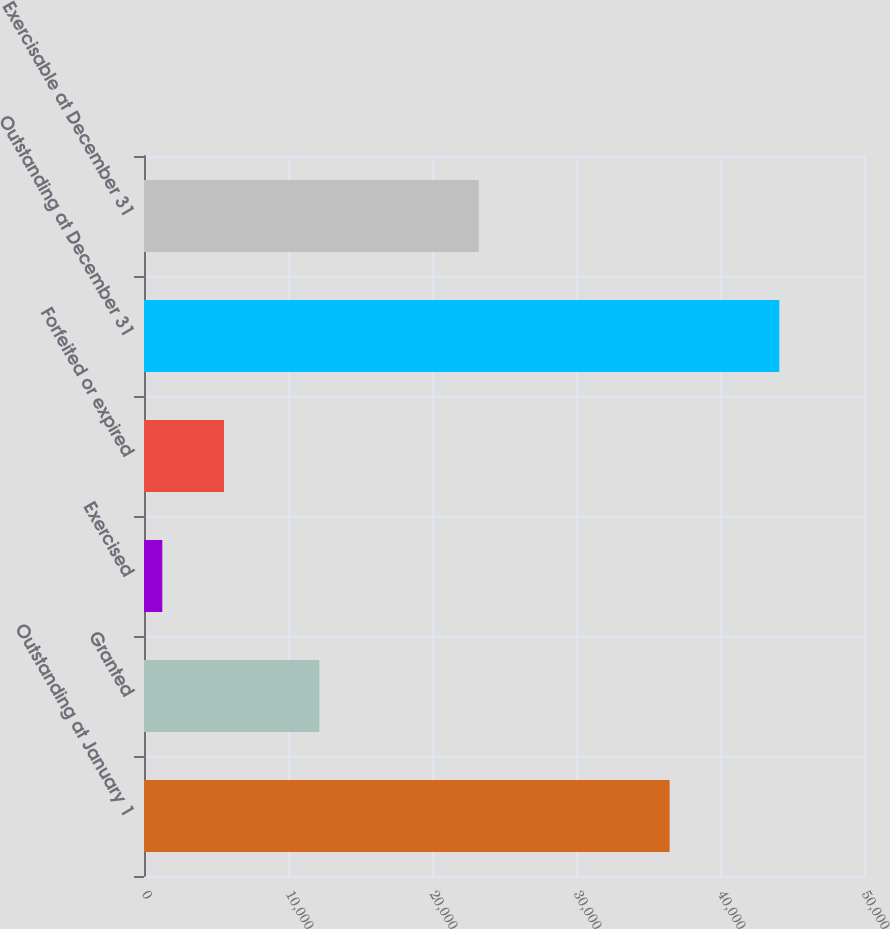<chart> <loc_0><loc_0><loc_500><loc_500><bar_chart><fcel>Outstanding at January 1<fcel>Granted<fcel>Exercised<fcel>Forfeited or expired<fcel>Outstanding at December 31<fcel>Exercisable at December 31<nl><fcel>36502<fcel>12179<fcel>1271<fcel>5555.9<fcel>44120<fcel>23248<nl></chart> 